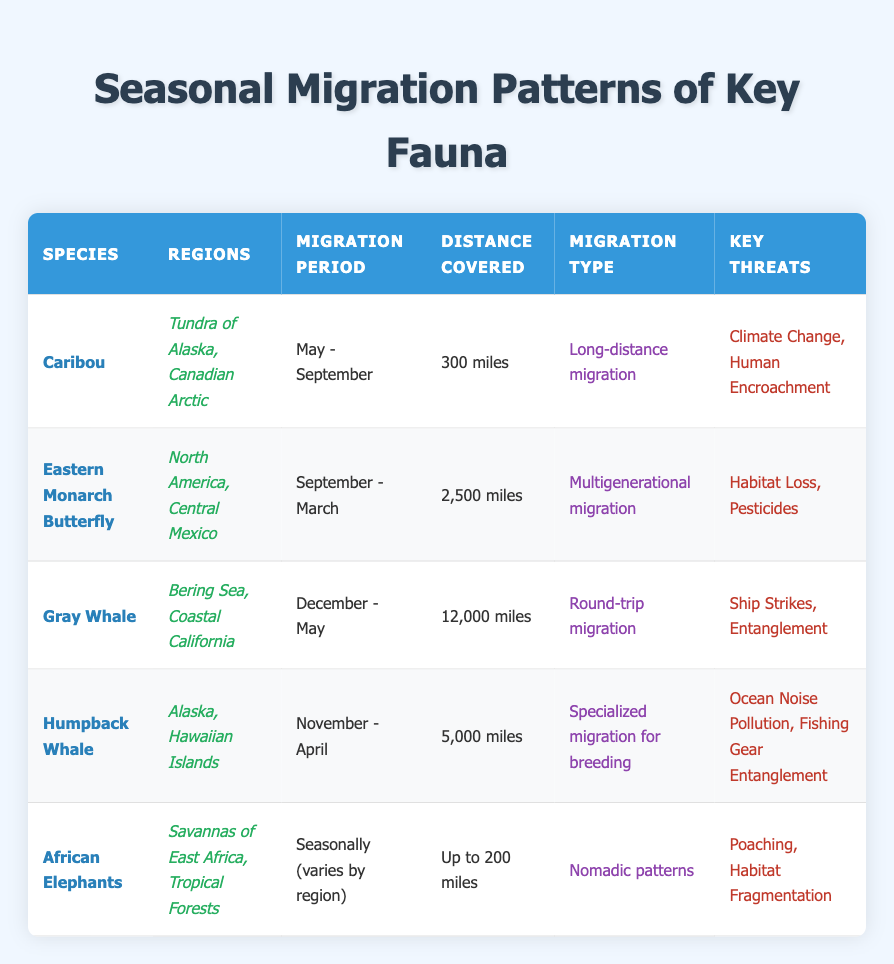What is the migration period for the Caribou? Looking at the table, the row for Caribou shows that its migration period is specified as "May - September."
Answer: May - September How far do Eastern Monarch Butterflies migrate? Referring to the row for Eastern Monarch Butterfly, we see that the distance covered during migration is "2,500 miles."
Answer: 2,500 miles Do Humpback Whales engage in long-distance migration? From the table, Humpback Whales have a migration type classified as specialized migration for breeding, which indicates that it is focused rather than long-distance in general terms. Thus, the answer is no.
Answer: No What are the key threats faced by African Elephants? Looking at the row for African Elephants, we can find the key threats listed as "Poaching" and "Habitat Fragmentation."
Answer: Poaching, Habitat Fragmentation Which species migrate during the winter months? By scanning the table, the species that migrate during winter months include Gray Whales (December - May) and Humpback Whales (November - April). We can conclude there are two species known for winter migrations.
Answer: Gray Whale, Humpback Whale What is the total distance covered by Gray Whales? The Gray Whale’s distance covered is stated as "12,000 miles." Thus, this direct value represents the total distance covered by this species alone during its migration.
Answer: 12,000 miles Are the Eastern Monarch Butterflies and Humpback Whales threatened by the same issues? Upon analyzing the threats, Eastern Monarch Butterflies face "Habitat Loss" and "Pesticides," while Humpback Whales are at risk of "Ocean Noise Pollution" and "Fishing Gear Entanglement." Since there is no overlap in their key threats, the answer is no.
Answer: No During which months do African Elephants typically migrate? The table indicates that African Elephants migrate seasonally; however, it varies by region, so specific months are not mentioned. Therefore, the answer cannot be narrowed down to specific months.
Answer: Varies by region What type of migration do Gray Whales undertake? The migration type for Gray Whales is defined as "Round-trip migration" in the table, indicating that they travel to a location and then return to their original location.
Answer: Round-trip migration 